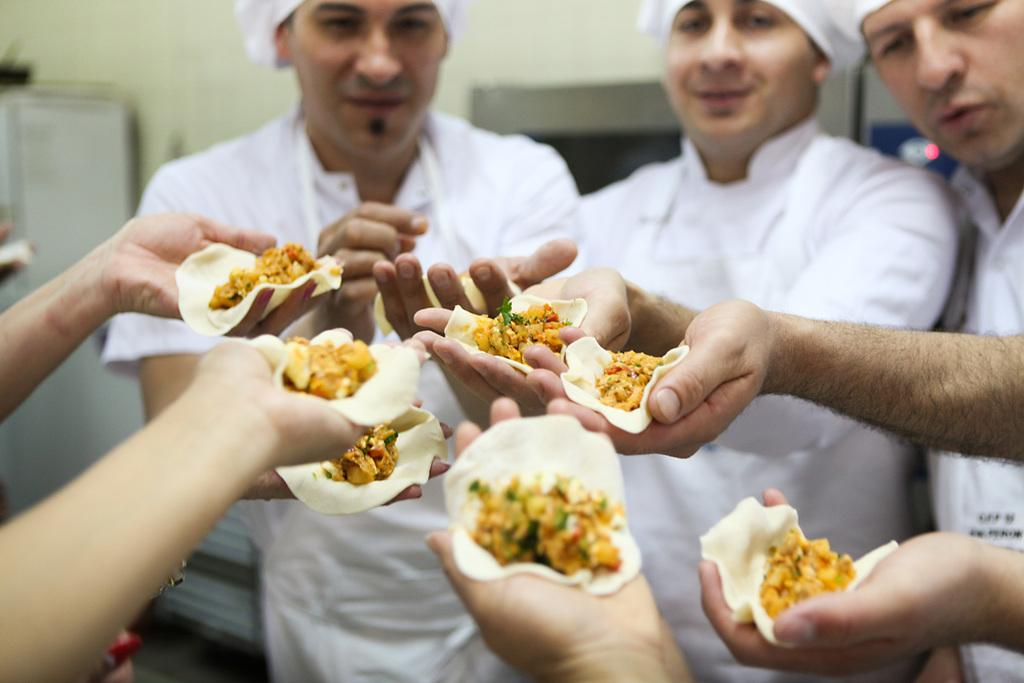What type of people are present in the image? There are men in the image. What are the men doing in the image? The men are standing in the image. What are the men holding in their hands? The men are holding food in their hands. What type of root can be seen growing in the image? There is no root present in the image. How many bags of popcorn are visible in the image? There is no popcorn present in the image. 